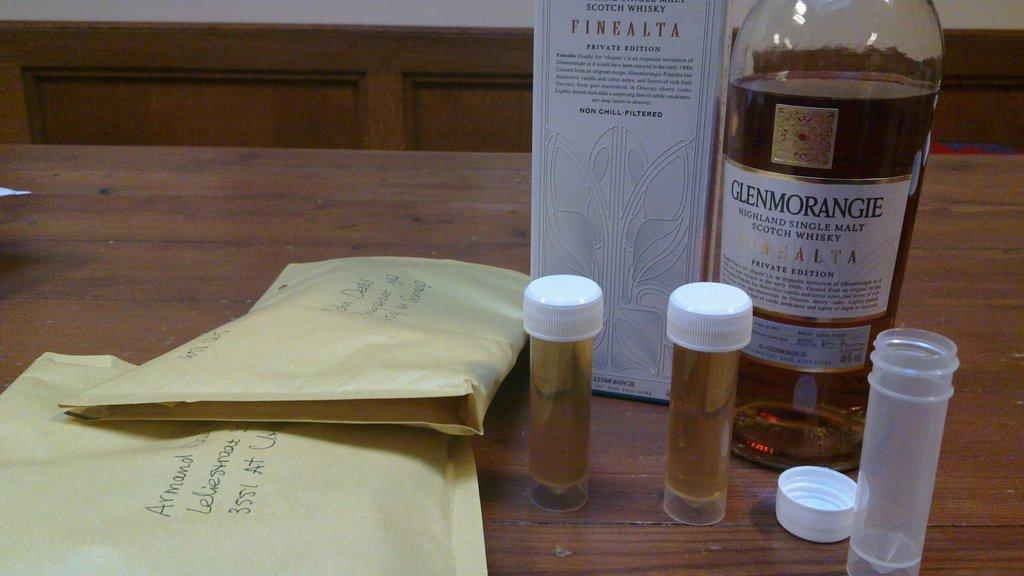<image>
Offer a succinct explanation of the picture presented. A bottle of Glenmorangie whiskey is present next to some vials and envelopes. 